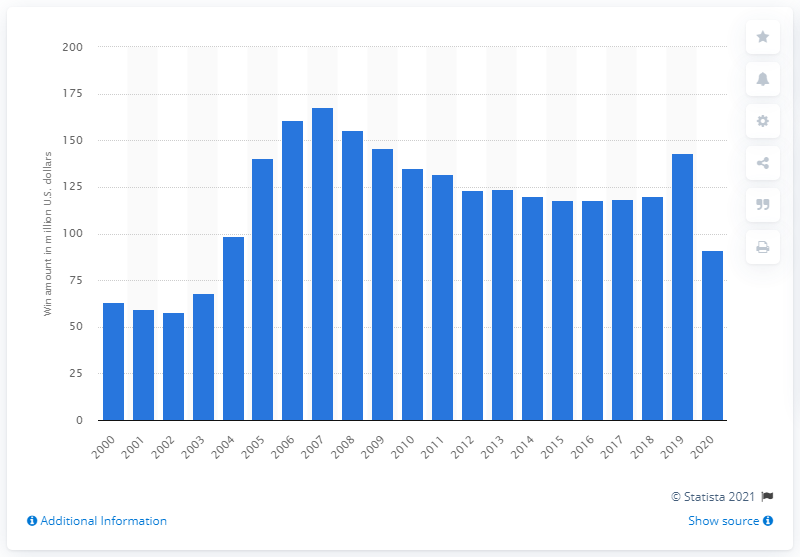Outline some significant characteristics in this image. In 2020, the amount of money won in casino poker games in Nevada was $91.36 million. 